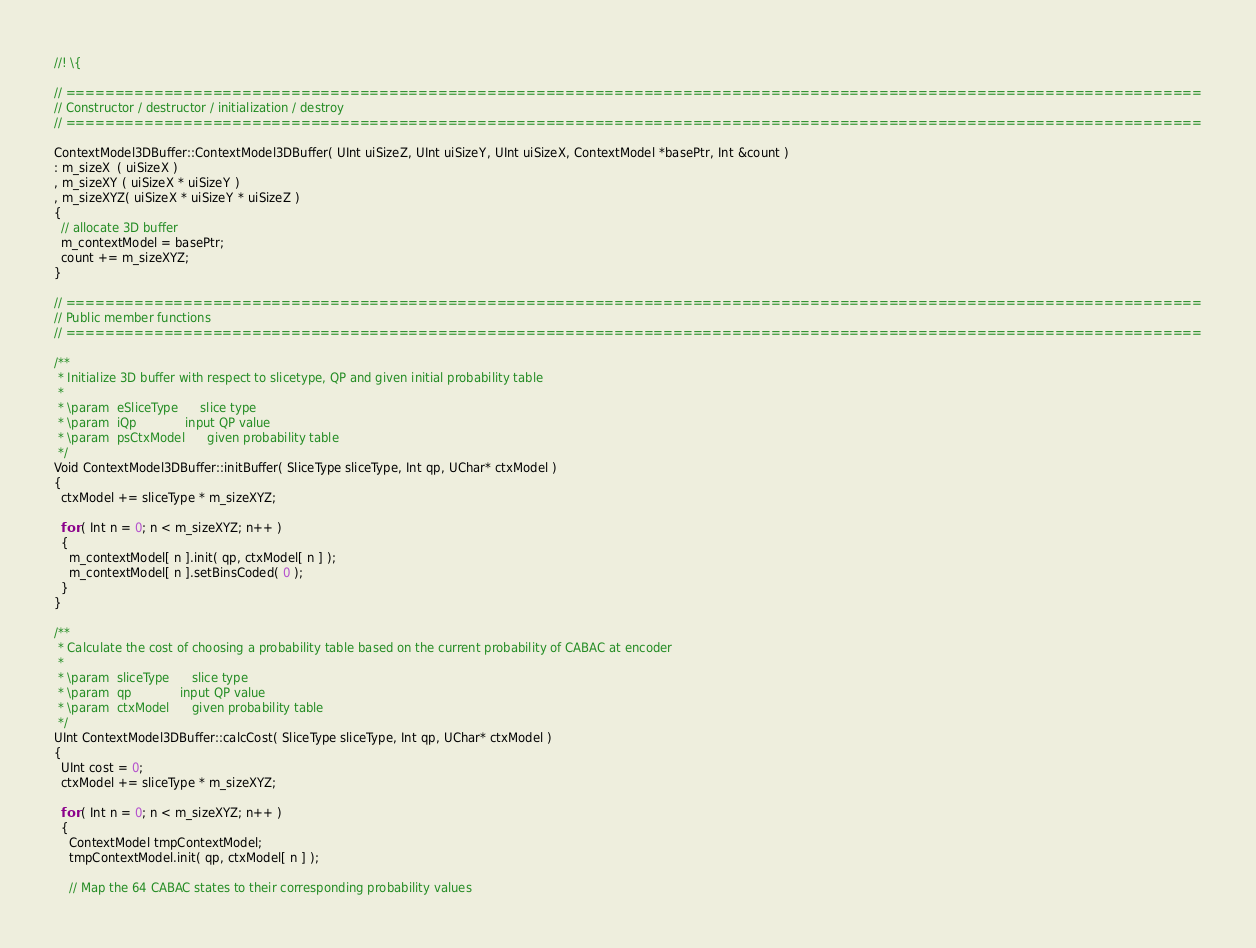Convert code to text. <code><loc_0><loc_0><loc_500><loc_500><_C++_>//! \{

// ====================================================================================================================
// Constructor / destructor / initialization / destroy
// ====================================================================================================================

ContextModel3DBuffer::ContextModel3DBuffer( UInt uiSizeZ, UInt uiSizeY, UInt uiSizeX, ContextModel *basePtr, Int &count )
: m_sizeX  ( uiSizeX )
, m_sizeXY ( uiSizeX * uiSizeY )
, m_sizeXYZ( uiSizeX * uiSizeY * uiSizeZ )
{
  // allocate 3D buffer
  m_contextModel = basePtr;
  count += m_sizeXYZ;
}

// ====================================================================================================================
// Public member functions
// ====================================================================================================================

/**
 * Initialize 3D buffer with respect to slicetype, QP and given initial probability table
 *
 * \param  eSliceType      slice type
 * \param  iQp             input QP value
 * \param  psCtxModel      given probability table
 */
Void ContextModel3DBuffer::initBuffer( SliceType sliceType, Int qp, UChar* ctxModel )
{
  ctxModel += sliceType * m_sizeXYZ;
  
  for ( Int n = 0; n < m_sizeXYZ; n++ )
  {
    m_contextModel[ n ].init( qp, ctxModel[ n ] );
    m_contextModel[ n ].setBinsCoded( 0 );
  }
}

/**
 * Calculate the cost of choosing a probability table based on the current probability of CABAC at encoder
 *
 * \param  sliceType      slice type
 * \param  qp             input QP value
 * \param  ctxModel      given probability table
 */
UInt ContextModel3DBuffer::calcCost( SliceType sliceType, Int qp, UChar* ctxModel )
{
  UInt cost = 0;
  ctxModel += sliceType * m_sizeXYZ;

  for ( Int n = 0; n < m_sizeXYZ; n++ )
  {
    ContextModel tmpContextModel;
    tmpContextModel.init( qp, ctxModel[ n ] );

    // Map the 64 CABAC states to their corresponding probability values</code> 